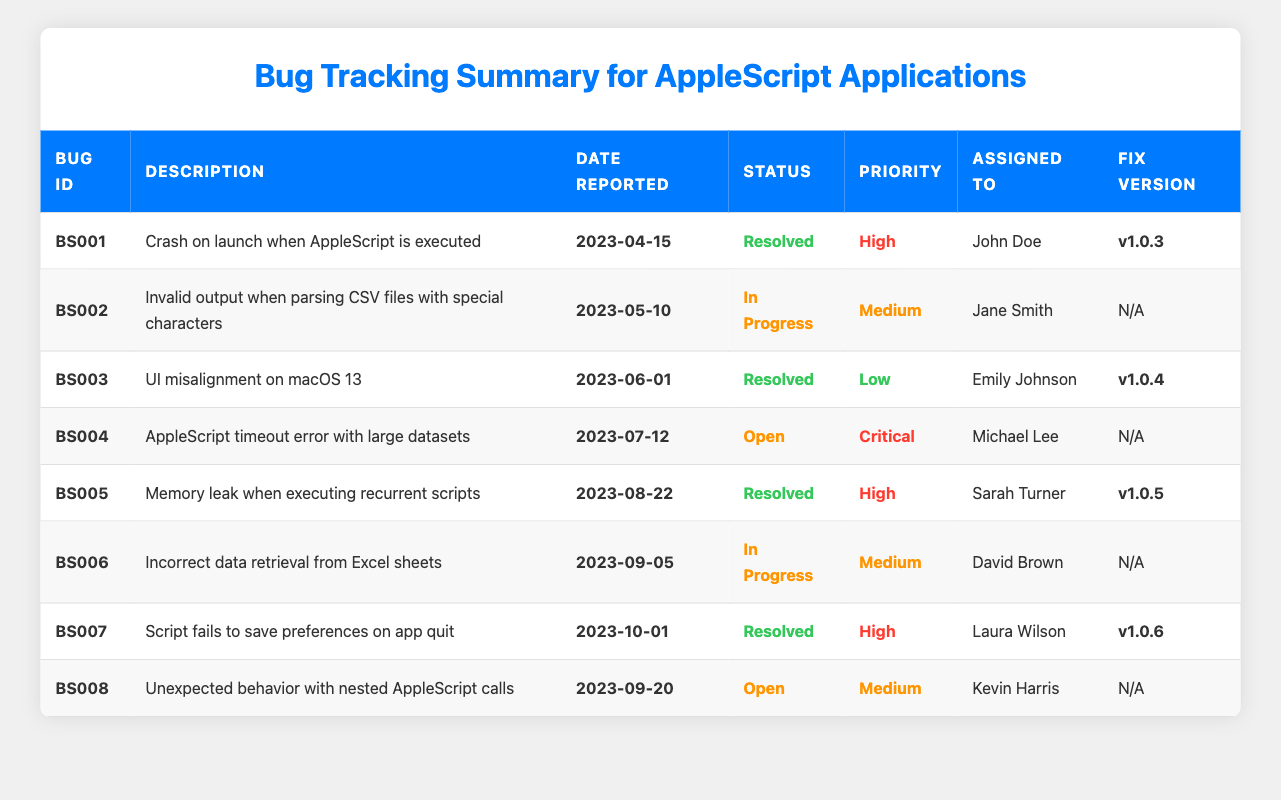What is the bug ID of the bug related to a memory leak? In the table, under the "Bug ID" column, the entry that corresponds to the description "Memory leak when executing recurrent scripts" is **BS005**.
Answer: BS005 Who resolved the bug regarding the crash on launch when AppleScript is executed? By looking at the "Assigned To" column for the bug with ID **BS001**, it states that John Doe resolved this issue.
Answer: John Doe How many bugs are currently open? There are two entries in the "Status" column that indicate "Open": **BS004** and **BS008**. So, there are 2 open bugs.
Answer: 2 What is the priority level of the bug with ID BS006? The "Priority" column shows that the entry for bug ID **BS006** indicates a priority of "Medium."
Answer: Medium Is there a bug in "In Progress" status that has high priority? The bugs in "In Progress" status are **BS002** and **BS006**, both of which have a priority of Medium, thus confirming that there are no "In Progress" bugs with high priority.
Answer: No What is the fix version for the bug dealing with the timestamp error? In the table, looking at the description for the bug titled "AppleScript timeout error with large datasets," there is no fix version provided, as indicated by "N/A."
Answer: N/A Which bug was reported first, and what is its status? The earliest date listed for a bug is **2023-04-15** for bug **BS001**, which has a status of "Resolved." Hence, this bug was the first reported.
Answer: BS001, Resolved How many bugs were resolved in total, and what percentage does that represent? Searching through the "Status" column, there are five resolved bugs (**BS001**, **BS003**, **BS005**, **BS007**). There are eight total bugs, therefore (5/8) * 100 = 62.5%.
Answer: 62.5% What is the description of the bug that was last reported? The last reported date in the table is **2023-10-01**, which corresponds to bug **BS007** with the description: "Script fails to save preferences on app quit."
Answer: Script fails to save preferences on app quit Which user has the most bugs assigned to them? Evaluating the "Assigned To" column, John Doe has 1, Jane Smith has 1, Emily Johnson has 1, Michael Lee has 1, Sarah Turner has 1, David Brown has 1, Laura Wilson has 1, and Kevin Harris has 1. So, each user has one bug assigned.
Answer: No user has more assigned bugs 